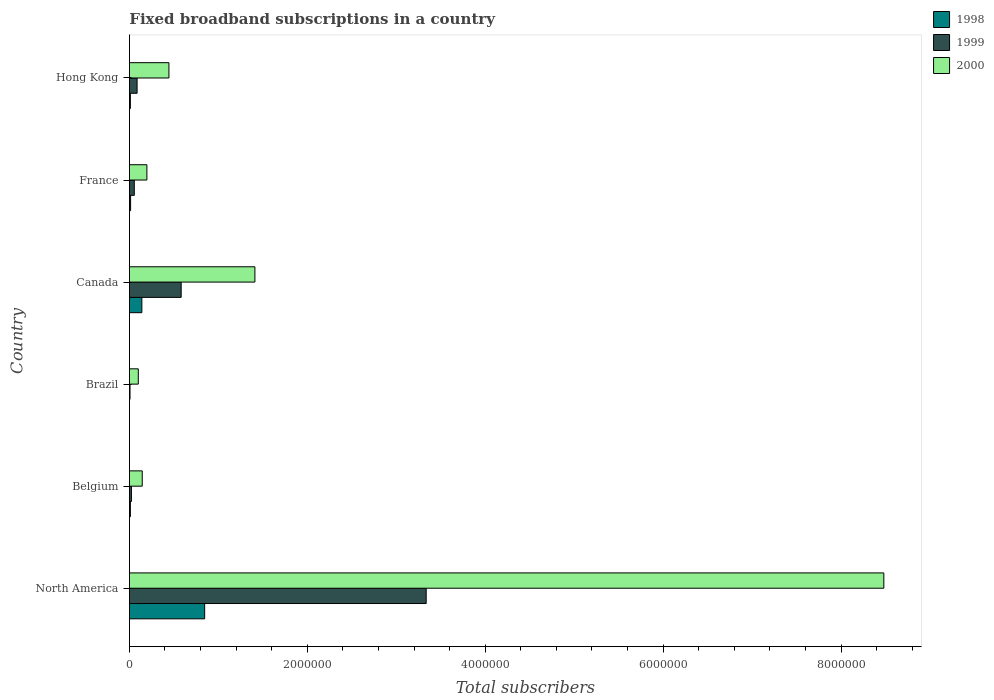Are the number of bars per tick equal to the number of legend labels?
Ensure brevity in your answer.  Yes. Are the number of bars on each tick of the Y-axis equal?
Provide a short and direct response. Yes. How many bars are there on the 1st tick from the top?
Offer a terse response. 3. In how many cases, is the number of bars for a given country not equal to the number of legend labels?
Provide a short and direct response. 0. What is the number of broadband subscriptions in 1999 in Hong Kong?
Your answer should be very brief. 8.65e+04. Across all countries, what is the maximum number of broadband subscriptions in 1998?
Offer a terse response. 8.46e+05. Across all countries, what is the minimum number of broadband subscriptions in 1999?
Keep it short and to the point. 7000. What is the total number of broadband subscriptions in 2000 in the graph?
Offer a very short reply. 1.08e+07. What is the difference between the number of broadband subscriptions in 1999 in Brazil and that in Canada?
Give a very brief answer. -5.75e+05. What is the difference between the number of broadband subscriptions in 2000 in North America and the number of broadband subscriptions in 1998 in Brazil?
Make the answer very short. 8.48e+06. What is the average number of broadband subscriptions in 2000 per country?
Offer a terse response. 1.80e+06. What is the difference between the number of broadband subscriptions in 2000 and number of broadband subscriptions in 1998 in Canada?
Provide a succinct answer. 1.27e+06. In how many countries, is the number of broadband subscriptions in 1998 greater than 4400000 ?
Your answer should be very brief. 0. What is the ratio of the number of broadband subscriptions in 1998 in Brazil to that in North America?
Your answer should be very brief. 0. Is the difference between the number of broadband subscriptions in 2000 in Brazil and North America greater than the difference between the number of broadband subscriptions in 1998 in Brazil and North America?
Make the answer very short. No. What is the difference between the highest and the second highest number of broadband subscriptions in 1998?
Your answer should be compact. 7.06e+05. What is the difference between the highest and the lowest number of broadband subscriptions in 2000?
Give a very brief answer. 8.38e+06. Is the sum of the number of broadband subscriptions in 1998 in Canada and France greater than the maximum number of broadband subscriptions in 1999 across all countries?
Make the answer very short. No. What does the 3rd bar from the top in France represents?
Make the answer very short. 1998. What does the 3rd bar from the bottom in France represents?
Offer a very short reply. 2000. Are all the bars in the graph horizontal?
Keep it short and to the point. Yes. Does the graph contain any zero values?
Provide a succinct answer. No. Where does the legend appear in the graph?
Ensure brevity in your answer.  Top right. How are the legend labels stacked?
Your answer should be very brief. Vertical. What is the title of the graph?
Provide a short and direct response. Fixed broadband subscriptions in a country. What is the label or title of the X-axis?
Your answer should be very brief. Total subscribers. What is the Total subscribers in 1998 in North America?
Offer a terse response. 8.46e+05. What is the Total subscribers in 1999 in North America?
Provide a short and direct response. 3.34e+06. What is the Total subscribers of 2000 in North America?
Ensure brevity in your answer.  8.48e+06. What is the Total subscribers in 1998 in Belgium?
Provide a succinct answer. 1.09e+04. What is the Total subscribers of 1999 in Belgium?
Offer a very short reply. 2.30e+04. What is the Total subscribers of 2000 in Belgium?
Your answer should be very brief. 1.44e+05. What is the Total subscribers in 1999 in Brazil?
Keep it short and to the point. 7000. What is the Total subscribers of 2000 in Brazil?
Give a very brief answer. 1.00e+05. What is the Total subscribers of 1998 in Canada?
Keep it short and to the point. 1.40e+05. What is the Total subscribers of 1999 in Canada?
Your response must be concise. 5.82e+05. What is the Total subscribers in 2000 in Canada?
Offer a terse response. 1.41e+06. What is the Total subscribers of 1998 in France?
Your answer should be compact. 1.35e+04. What is the Total subscribers in 1999 in France?
Provide a succinct answer. 5.50e+04. What is the Total subscribers in 2000 in France?
Your answer should be very brief. 1.97e+05. What is the Total subscribers of 1998 in Hong Kong?
Keep it short and to the point. 1.10e+04. What is the Total subscribers in 1999 in Hong Kong?
Offer a very short reply. 8.65e+04. What is the Total subscribers of 2000 in Hong Kong?
Your answer should be very brief. 4.44e+05. Across all countries, what is the maximum Total subscribers in 1998?
Offer a terse response. 8.46e+05. Across all countries, what is the maximum Total subscribers of 1999?
Your answer should be compact. 3.34e+06. Across all countries, what is the maximum Total subscribers of 2000?
Ensure brevity in your answer.  8.48e+06. Across all countries, what is the minimum Total subscribers in 1999?
Keep it short and to the point. 7000. What is the total Total subscribers in 1998 in the graph?
Your response must be concise. 1.02e+06. What is the total Total subscribers of 1999 in the graph?
Your answer should be compact. 4.09e+06. What is the total Total subscribers in 2000 in the graph?
Offer a terse response. 1.08e+07. What is the difference between the Total subscribers in 1998 in North America and that in Belgium?
Your answer should be very brief. 8.35e+05. What is the difference between the Total subscribers of 1999 in North America and that in Belgium?
Make the answer very short. 3.31e+06. What is the difference between the Total subscribers of 2000 in North America and that in Belgium?
Provide a short and direct response. 8.34e+06. What is the difference between the Total subscribers in 1998 in North America and that in Brazil?
Your answer should be compact. 8.45e+05. What is the difference between the Total subscribers of 1999 in North America and that in Brazil?
Give a very brief answer. 3.33e+06. What is the difference between the Total subscribers of 2000 in North America and that in Brazil?
Make the answer very short. 8.38e+06. What is the difference between the Total subscribers in 1998 in North America and that in Canada?
Offer a terse response. 7.06e+05. What is the difference between the Total subscribers of 1999 in North America and that in Canada?
Your answer should be very brief. 2.75e+06. What is the difference between the Total subscribers in 2000 in North America and that in Canada?
Your answer should be very brief. 7.07e+06. What is the difference between the Total subscribers of 1998 in North America and that in France?
Ensure brevity in your answer.  8.32e+05. What is the difference between the Total subscribers of 1999 in North America and that in France?
Your answer should be very brief. 3.28e+06. What is the difference between the Total subscribers in 2000 in North America and that in France?
Your answer should be compact. 8.28e+06. What is the difference between the Total subscribers of 1998 in North America and that in Hong Kong?
Provide a succinct answer. 8.35e+05. What is the difference between the Total subscribers in 1999 in North America and that in Hong Kong?
Offer a terse response. 3.25e+06. What is the difference between the Total subscribers in 2000 in North America and that in Hong Kong?
Provide a succinct answer. 8.04e+06. What is the difference between the Total subscribers of 1998 in Belgium and that in Brazil?
Your answer should be very brief. 9924. What is the difference between the Total subscribers in 1999 in Belgium and that in Brazil?
Provide a succinct answer. 1.60e+04. What is the difference between the Total subscribers in 2000 in Belgium and that in Brazil?
Offer a terse response. 4.42e+04. What is the difference between the Total subscribers in 1998 in Belgium and that in Canada?
Give a very brief answer. -1.29e+05. What is the difference between the Total subscribers of 1999 in Belgium and that in Canada?
Your response must be concise. -5.59e+05. What is the difference between the Total subscribers in 2000 in Belgium and that in Canada?
Give a very brief answer. -1.27e+06. What is the difference between the Total subscribers of 1998 in Belgium and that in France?
Keep it short and to the point. -2540. What is the difference between the Total subscribers in 1999 in Belgium and that in France?
Provide a short and direct response. -3.20e+04. What is the difference between the Total subscribers of 2000 in Belgium and that in France?
Offer a terse response. -5.24e+04. What is the difference between the Total subscribers in 1998 in Belgium and that in Hong Kong?
Provide a short and direct response. -76. What is the difference between the Total subscribers in 1999 in Belgium and that in Hong Kong?
Provide a succinct answer. -6.35e+04. What is the difference between the Total subscribers of 2000 in Belgium and that in Hong Kong?
Provide a short and direct response. -3.00e+05. What is the difference between the Total subscribers of 1998 in Brazil and that in Canada?
Offer a terse response. -1.39e+05. What is the difference between the Total subscribers in 1999 in Brazil and that in Canada?
Provide a succinct answer. -5.75e+05. What is the difference between the Total subscribers in 2000 in Brazil and that in Canada?
Keep it short and to the point. -1.31e+06. What is the difference between the Total subscribers in 1998 in Brazil and that in France?
Give a very brief answer. -1.25e+04. What is the difference between the Total subscribers in 1999 in Brazil and that in France?
Offer a very short reply. -4.80e+04. What is the difference between the Total subscribers in 2000 in Brazil and that in France?
Offer a terse response. -9.66e+04. What is the difference between the Total subscribers in 1998 in Brazil and that in Hong Kong?
Your answer should be very brief. -10000. What is the difference between the Total subscribers of 1999 in Brazil and that in Hong Kong?
Your response must be concise. -7.95e+04. What is the difference between the Total subscribers in 2000 in Brazil and that in Hong Kong?
Your response must be concise. -3.44e+05. What is the difference between the Total subscribers in 1998 in Canada and that in France?
Offer a very short reply. 1.27e+05. What is the difference between the Total subscribers of 1999 in Canada and that in France?
Your response must be concise. 5.27e+05. What is the difference between the Total subscribers in 2000 in Canada and that in France?
Provide a short and direct response. 1.21e+06. What is the difference between the Total subscribers of 1998 in Canada and that in Hong Kong?
Your answer should be compact. 1.29e+05. What is the difference between the Total subscribers of 1999 in Canada and that in Hong Kong?
Offer a terse response. 4.96e+05. What is the difference between the Total subscribers in 2000 in Canada and that in Hong Kong?
Keep it short and to the point. 9.66e+05. What is the difference between the Total subscribers in 1998 in France and that in Hong Kong?
Your answer should be compact. 2464. What is the difference between the Total subscribers of 1999 in France and that in Hong Kong?
Keep it short and to the point. -3.15e+04. What is the difference between the Total subscribers in 2000 in France and that in Hong Kong?
Your answer should be compact. -2.48e+05. What is the difference between the Total subscribers of 1998 in North America and the Total subscribers of 1999 in Belgium?
Keep it short and to the point. 8.23e+05. What is the difference between the Total subscribers in 1998 in North America and the Total subscribers in 2000 in Belgium?
Your answer should be very brief. 7.02e+05. What is the difference between the Total subscribers of 1999 in North America and the Total subscribers of 2000 in Belgium?
Make the answer very short. 3.19e+06. What is the difference between the Total subscribers in 1998 in North America and the Total subscribers in 1999 in Brazil?
Your answer should be very brief. 8.39e+05. What is the difference between the Total subscribers in 1998 in North America and the Total subscribers in 2000 in Brazil?
Your answer should be very brief. 7.46e+05. What is the difference between the Total subscribers of 1999 in North America and the Total subscribers of 2000 in Brazil?
Your answer should be very brief. 3.24e+06. What is the difference between the Total subscribers of 1998 in North America and the Total subscribers of 1999 in Canada?
Your answer should be compact. 2.64e+05. What is the difference between the Total subscribers in 1998 in North America and the Total subscribers in 2000 in Canada?
Provide a succinct answer. -5.65e+05. What is the difference between the Total subscribers of 1999 in North America and the Total subscribers of 2000 in Canada?
Make the answer very short. 1.93e+06. What is the difference between the Total subscribers in 1998 in North America and the Total subscribers in 1999 in France?
Provide a succinct answer. 7.91e+05. What is the difference between the Total subscribers in 1998 in North America and the Total subscribers in 2000 in France?
Your response must be concise. 6.49e+05. What is the difference between the Total subscribers in 1999 in North America and the Total subscribers in 2000 in France?
Provide a succinct answer. 3.14e+06. What is the difference between the Total subscribers in 1998 in North America and the Total subscribers in 1999 in Hong Kong?
Provide a succinct answer. 7.59e+05. What is the difference between the Total subscribers in 1998 in North America and the Total subscribers in 2000 in Hong Kong?
Provide a succinct answer. 4.01e+05. What is the difference between the Total subscribers in 1999 in North America and the Total subscribers in 2000 in Hong Kong?
Offer a very short reply. 2.89e+06. What is the difference between the Total subscribers of 1998 in Belgium and the Total subscribers of 1999 in Brazil?
Provide a succinct answer. 3924. What is the difference between the Total subscribers in 1998 in Belgium and the Total subscribers in 2000 in Brazil?
Keep it short and to the point. -8.91e+04. What is the difference between the Total subscribers in 1999 in Belgium and the Total subscribers in 2000 in Brazil?
Offer a terse response. -7.70e+04. What is the difference between the Total subscribers in 1998 in Belgium and the Total subscribers in 1999 in Canada?
Give a very brief answer. -5.71e+05. What is the difference between the Total subscribers in 1998 in Belgium and the Total subscribers in 2000 in Canada?
Your response must be concise. -1.40e+06. What is the difference between the Total subscribers of 1999 in Belgium and the Total subscribers of 2000 in Canada?
Give a very brief answer. -1.39e+06. What is the difference between the Total subscribers of 1998 in Belgium and the Total subscribers of 1999 in France?
Provide a short and direct response. -4.41e+04. What is the difference between the Total subscribers in 1998 in Belgium and the Total subscribers in 2000 in France?
Keep it short and to the point. -1.86e+05. What is the difference between the Total subscribers of 1999 in Belgium and the Total subscribers of 2000 in France?
Ensure brevity in your answer.  -1.74e+05. What is the difference between the Total subscribers of 1998 in Belgium and the Total subscribers of 1999 in Hong Kong?
Offer a very short reply. -7.55e+04. What is the difference between the Total subscribers in 1998 in Belgium and the Total subscribers in 2000 in Hong Kong?
Your response must be concise. -4.34e+05. What is the difference between the Total subscribers of 1999 in Belgium and the Total subscribers of 2000 in Hong Kong?
Keep it short and to the point. -4.21e+05. What is the difference between the Total subscribers in 1998 in Brazil and the Total subscribers in 1999 in Canada?
Your response must be concise. -5.81e+05. What is the difference between the Total subscribers of 1998 in Brazil and the Total subscribers of 2000 in Canada?
Make the answer very short. -1.41e+06. What is the difference between the Total subscribers of 1999 in Brazil and the Total subscribers of 2000 in Canada?
Your answer should be compact. -1.40e+06. What is the difference between the Total subscribers of 1998 in Brazil and the Total subscribers of 1999 in France?
Give a very brief answer. -5.40e+04. What is the difference between the Total subscribers in 1998 in Brazil and the Total subscribers in 2000 in France?
Your answer should be compact. -1.96e+05. What is the difference between the Total subscribers in 1999 in Brazil and the Total subscribers in 2000 in France?
Keep it short and to the point. -1.90e+05. What is the difference between the Total subscribers in 1998 in Brazil and the Total subscribers in 1999 in Hong Kong?
Provide a succinct answer. -8.55e+04. What is the difference between the Total subscribers of 1998 in Brazil and the Total subscribers of 2000 in Hong Kong?
Offer a very short reply. -4.43e+05. What is the difference between the Total subscribers of 1999 in Brazil and the Total subscribers of 2000 in Hong Kong?
Your answer should be compact. -4.37e+05. What is the difference between the Total subscribers of 1998 in Canada and the Total subscribers of 1999 in France?
Your answer should be compact. 8.50e+04. What is the difference between the Total subscribers of 1998 in Canada and the Total subscribers of 2000 in France?
Your answer should be very brief. -5.66e+04. What is the difference between the Total subscribers in 1999 in Canada and the Total subscribers in 2000 in France?
Make the answer very short. 3.85e+05. What is the difference between the Total subscribers in 1998 in Canada and the Total subscribers in 1999 in Hong Kong?
Ensure brevity in your answer.  5.35e+04. What is the difference between the Total subscribers in 1998 in Canada and the Total subscribers in 2000 in Hong Kong?
Your response must be concise. -3.04e+05. What is the difference between the Total subscribers of 1999 in Canada and the Total subscribers of 2000 in Hong Kong?
Your answer should be compact. 1.38e+05. What is the difference between the Total subscribers in 1998 in France and the Total subscribers in 1999 in Hong Kong?
Your answer should be very brief. -7.30e+04. What is the difference between the Total subscribers of 1998 in France and the Total subscribers of 2000 in Hong Kong?
Your answer should be very brief. -4.31e+05. What is the difference between the Total subscribers in 1999 in France and the Total subscribers in 2000 in Hong Kong?
Keep it short and to the point. -3.89e+05. What is the average Total subscribers of 1998 per country?
Offer a very short reply. 1.70e+05. What is the average Total subscribers of 1999 per country?
Ensure brevity in your answer.  6.82e+05. What is the average Total subscribers of 2000 per country?
Offer a terse response. 1.80e+06. What is the difference between the Total subscribers in 1998 and Total subscribers in 1999 in North America?
Make the answer very short. -2.49e+06. What is the difference between the Total subscribers of 1998 and Total subscribers of 2000 in North America?
Offer a terse response. -7.63e+06. What is the difference between the Total subscribers in 1999 and Total subscribers in 2000 in North America?
Offer a terse response. -5.14e+06. What is the difference between the Total subscribers in 1998 and Total subscribers in 1999 in Belgium?
Keep it short and to the point. -1.21e+04. What is the difference between the Total subscribers of 1998 and Total subscribers of 2000 in Belgium?
Ensure brevity in your answer.  -1.33e+05. What is the difference between the Total subscribers of 1999 and Total subscribers of 2000 in Belgium?
Ensure brevity in your answer.  -1.21e+05. What is the difference between the Total subscribers of 1998 and Total subscribers of 1999 in Brazil?
Provide a succinct answer. -6000. What is the difference between the Total subscribers in 1998 and Total subscribers in 2000 in Brazil?
Make the answer very short. -9.90e+04. What is the difference between the Total subscribers in 1999 and Total subscribers in 2000 in Brazil?
Make the answer very short. -9.30e+04. What is the difference between the Total subscribers in 1998 and Total subscribers in 1999 in Canada?
Give a very brief answer. -4.42e+05. What is the difference between the Total subscribers of 1998 and Total subscribers of 2000 in Canada?
Make the answer very short. -1.27e+06. What is the difference between the Total subscribers in 1999 and Total subscribers in 2000 in Canada?
Offer a very short reply. -8.29e+05. What is the difference between the Total subscribers of 1998 and Total subscribers of 1999 in France?
Provide a short and direct response. -4.15e+04. What is the difference between the Total subscribers of 1998 and Total subscribers of 2000 in France?
Your response must be concise. -1.83e+05. What is the difference between the Total subscribers in 1999 and Total subscribers in 2000 in France?
Provide a short and direct response. -1.42e+05. What is the difference between the Total subscribers of 1998 and Total subscribers of 1999 in Hong Kong?
Your answer should be very brief. -7.55e+04. What is the difference between the Total subscribers in 1998 and Total subscribers in 2000 in Hong Kong?
Provide a short and direct response. -4.33e+05. What is the difference between the Total subscribers of 1999 and Total subscribers of 2000 in Hong Kong?
Provide a succinct answer. -3.58e+05. What is the ratio of the Total subscribers of 1998 in North America to that in Belgium?
Your response must be concise. 77.44. What is the ratio of the Total subscribers of 1999 in North America to that in Belgium?
Your response must be concise. 145.06. What is the ratio of the Total subscribers of 2000 in North America to that in Belgium?
Provide a short and direct response. 58.81. What is the ratio of the Total subscribers in 1998 in North America to that in Brazil?
Your response must be concise. 845.9. What is the ratio of the Total subscribers in 1999 in North America to that in Brazil?
Give a very brief answer. 476.61. What is the ratio of the Total subscribers in 2000 in North America to that in Brazil?
Your answer should be compact. 84.81. What is the ratio of the Total subscribers of 1998 in North America to that in Canada?
Provide a short and direct response. 6.04. What is the ratio of the Total subscribers in 1999 in North America to that in Canada?
Offer a terse response. 5.73. What is the ratio of the Total subscribers in 2000 in North America to that in Canada?
Ensure brevity in your answer.  6.01. What is the ratio of the Total subscribers of 1998 in North America to that in France?
Provide a short and direct response. 62.83. What is the ratio of the Total subscribers of 1999 in North America to that in France?
Your response must be concise. 60.66. What is the ratio of the Total subscribers of 2000 in North America to that in France?
Keep it short and to the point. 43.14. What is the ratio of the Total subscribers in 1998 in North America to that in Hong Kong?
Offer a terse response. 76.9. What is the ratio of the Total subscribers of 1999 in North America to that in Hong Kong?
Offer a terse response. 38.58. What is the ratio of the Total subscribers in 2000 in North America to that in Hong Kong?
Your response must be concise. 19.08. What is the ratio of the Total subscribers in 1998 in Belgium to that in Brazil?
Provide a succinct answer. 10.92. What is the ratio of the Total subscribers in 1999 in Belgium to that in Brazil?
Your answer should be very brief. 3.29. What is the ratio of the Total subscribers of 2000 in Belgium to that in Brazil?
Provide a short and direct response. 1.44. What is the ratio of the Total subscribers of 1998 in Belgium to that in Canada?
Keep it short and to the point. 0.08. What is the ratio of the Total subscribers in 1999 in Belgium to that in Canada?
Your answer should be compact. 0.04. What is the ratio of the Total subscribers in 2000 in Belgium to that in Canada?
Keep it short and to the point. 0.1. What is the ratio of the Total subscribers of 1998 in Belgium to that in France?
Offer a very short reply. 0.81. What is the ratio of the Total subscribers in 1999 in Belgium to that in France?
Your answer should be very brief. 0.42. What is the ratio of the Total subscribers in 2000 in Belgium to that in France?
Provide a succinct answer. 0.73. What is the ratio of the Total subscribers of 1999 in Belgium to that in Hong Kong?
Provide a short and direct response. 0.27. What is the ratio of the Total subscribers in 2000 in Belgium to that in Hong Kong?
Give a very brief answer. 0.32. What is the ratio of the Total subscribers in 1998 in Brazil to that in Canada?
Make the answer very short. 0.01. What is the ratio of the Total subscribers in 1999 in Brazil to that in Canada?
Your answer should be very brief. 0.01. What is the ratio of the Total subscribers of 2000 in Brazil to that in Canada?
Your response must be concise. 0.07. What is the ratio of the Total subscribers in 1998 in Brazil to that in France?
Keep it short and to the point. 0.07. What is the ratio of the Total subscribers in 1999 in Brazil to that in France?
Your answer should be very brief. 0.13. What is the ratio of the Total subscribers of 2000 in Brazil to that in France?
Offer a terse response. 0.51. What is the ratio of the Total subscribers in 1998 in Brazil to that in Hong Kong?
Your answer should be very brief. 0.09. What is the ratio of the Total subscribers of 1999 in Brazil to that in Hong Kong?
Provide a succinct answer. 0.08. What is the ratio of the Total subscribers in 2000 in Brazil to that in Hong Kong?
Ensure brevity in your answer.  0.23. What is the ratio of the Total subscribers in 1998 in Canada to that in France?
Provide a short and direct response. 10.4. What is the ratio of the Total subscribers of 1999 in Canada to that in France?
Provide a succinct answer. 10.58. What is the ratio of the Total subscribers in 2000 in Canada to that in France?
Give a very brief answer. 7.18. What is the ratio of the Total subscribers of 1998 in Canada to that in Hong Kong?
Ensure brevity in your answer.  12.73. What is the ratio of the Total subscribers in 1999 in Canada to that in Hong Kong?
Keep it short and to the point. 6.73. What is the ratio of the Total subscribers of 2000 in Canada to that in Hong Kong?
Offer a very short reply. 3.17. What is the ratio of the Total subscribers in 1998 in France to that in Hong Kong?
Make the answer very short. 1.22. What is the ratio of the Total subscribers in 1999 in France to that in Hong Kong?
Provide a short and direct response. 0.64. What is the ratio of the Total subscribers of 2000 in France to that in Hong Kong?
Your answer should be compact. 0.44. What is the difference between the highest and the second highest Total subscribers in 1998?
Offer a terse response. 7.06e+05. What is the difference between the highest and the second highest Total subscribers in 1999?
Offer a very short reply. 2.75e+06. What is the difference between the highest and the second highest Total subscribers in 2000?
Provide a succinct answer. 7.07e+06. What is the difference between the highest and the lowest Total subscribers in 1998?
Ensure brevity in your answer.  8.45e+05. What is the difference between the highest and the lowest Total subscribers of 1999?
Provide a succinct answer. 3.33e+06. What is the difference between the highest and the lowest Total subscribers of 2000?
Ensure brevity in your answer.  8.38e+06. 